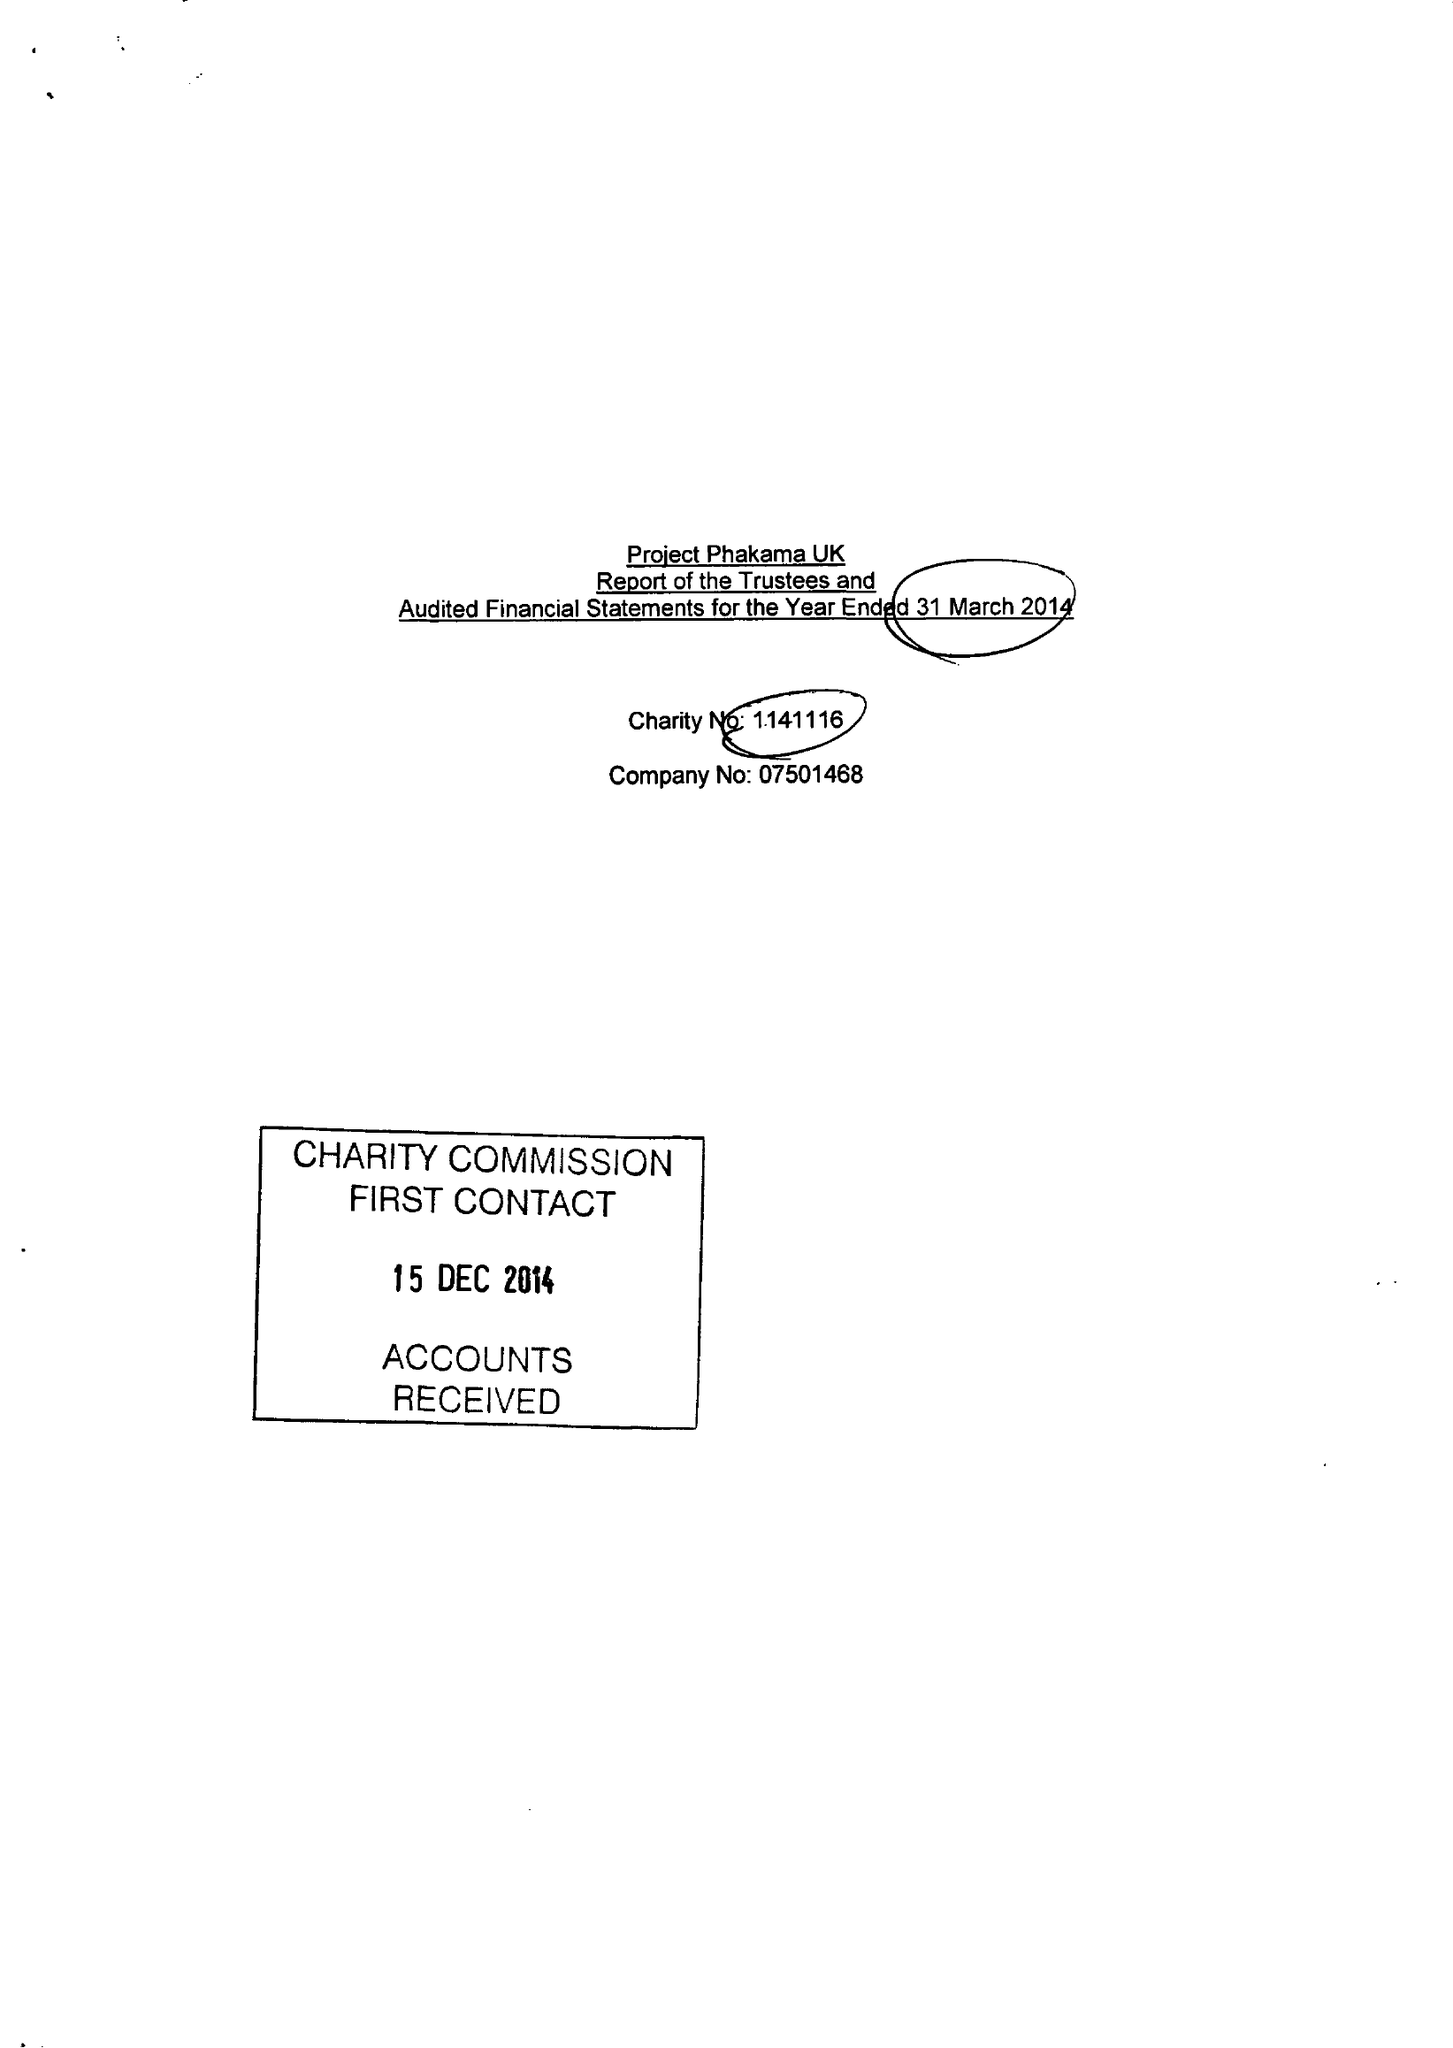What is the value for the spending_annually_in_british_pounds?
Answer the question using a single word or phrase. 234789.00 